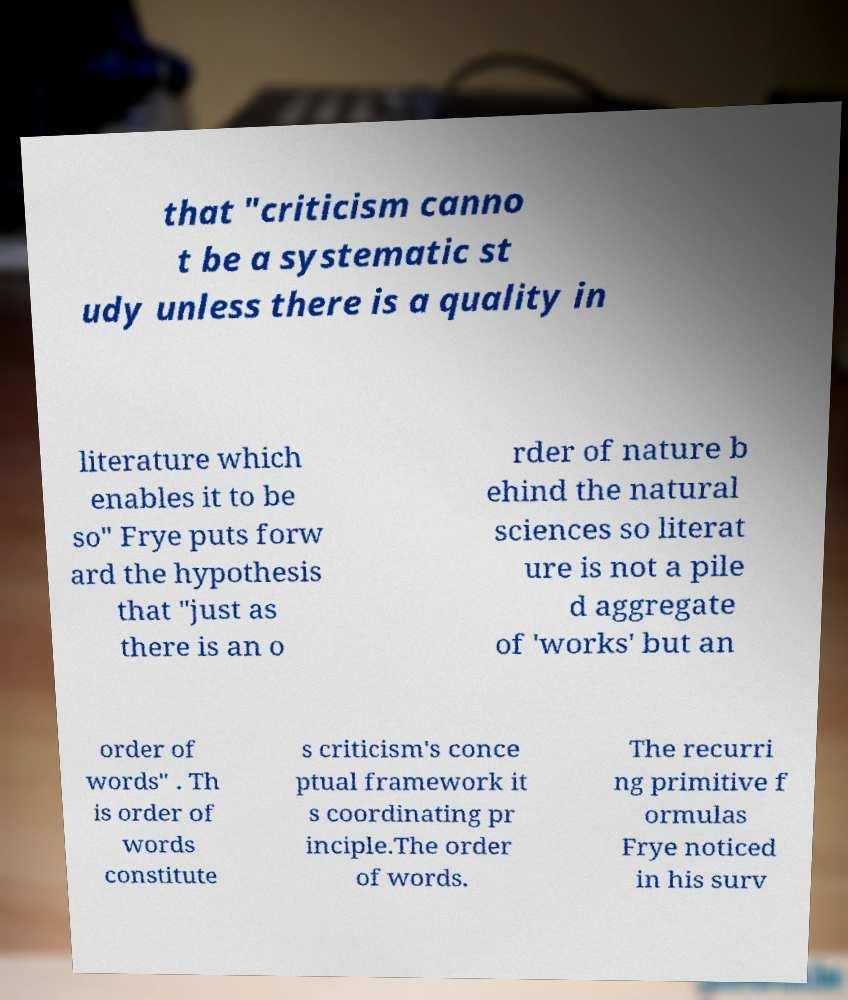There's text embedded in this image that I need extracted. Can you transcribe it verbatim? that "criticism canno t be a systematic st udy unless there is a quality in literature which enables it to be so" Frye puts forw ard the hypothesis that "just as there is an o rder of nature b ehind the natural sciences so literat ure is not a pile d aggregate of 'works' but an order of words" . Th is order of words constitute s criticism's conce ptual framework it s coordinating pr inciple.The order of words. The recurri ng primitive f ormulas Frye noticed in his surv 